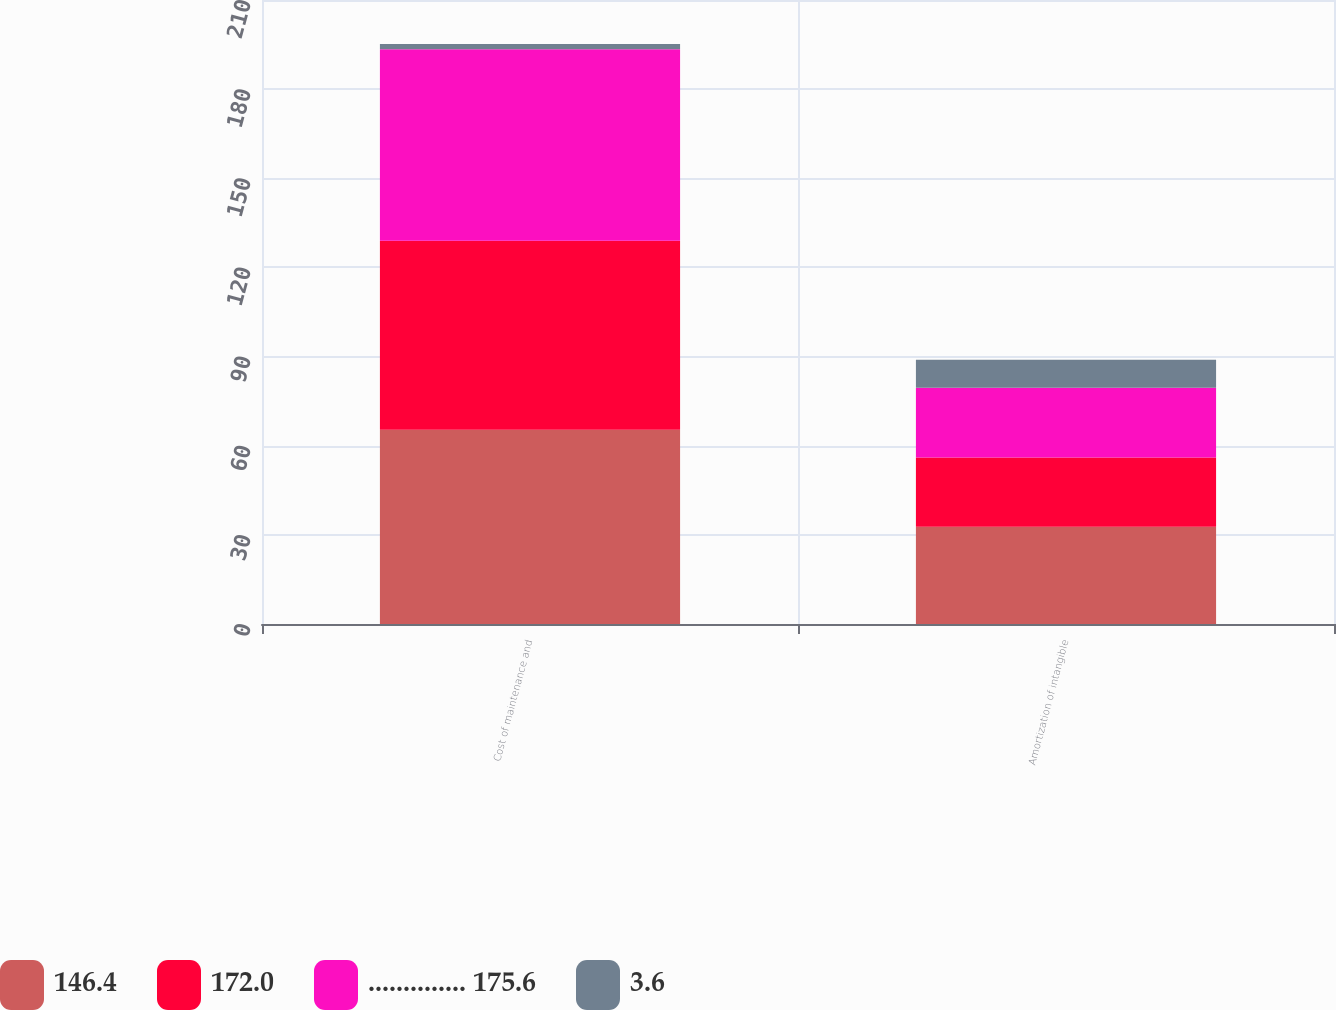Convert chart. <chart><loc_0><loc_0><loc_500><loc_500><stacked_bar_chart><ecel><fcel>Cost of maintenance and<fcel>Amortization of intangible<nl><fcel>146.4<fcel>65.4<fcel>32.7<nl><fcel>172.0<fcel>63.6<fcel>23.3<nl><fcel>.............. 175.6<fcel>64.4<fcel>23.5<nl><fcel>3.6<fcel>1.8<fcel>9.4<nl></chart> 